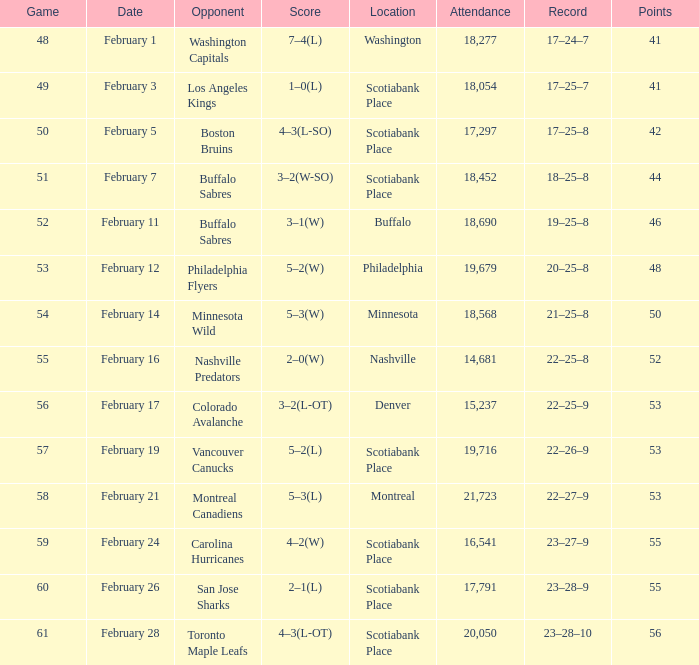What quantity of game has an audience of 18,690? 52.0. 